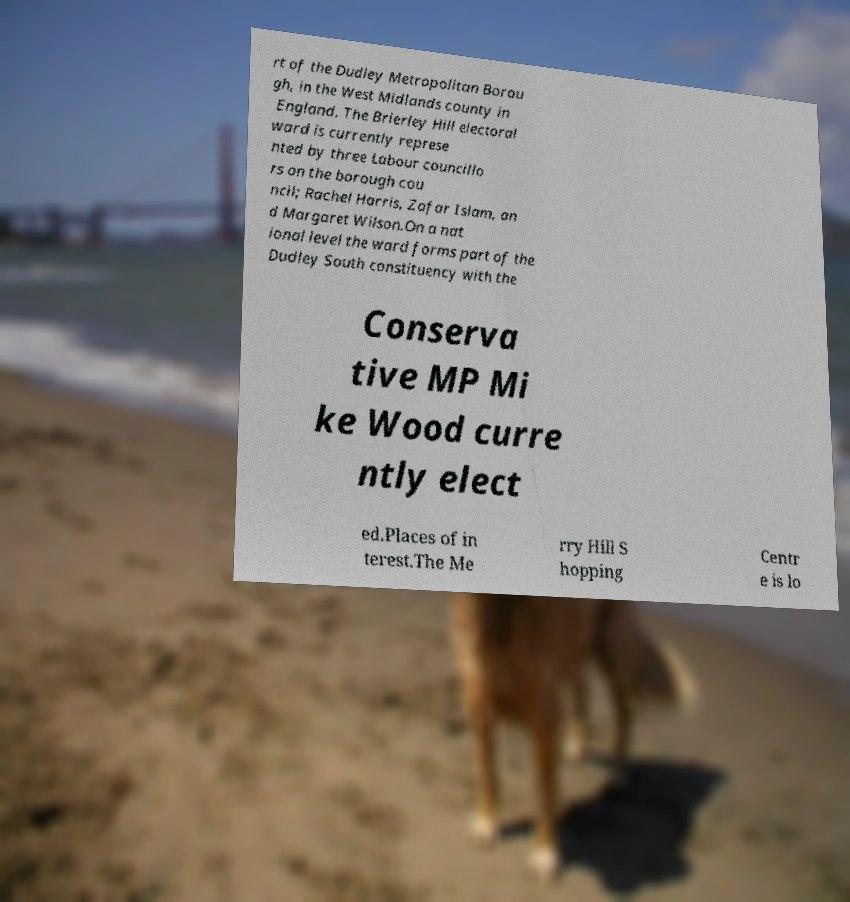Could you assist in decoding the text presented in this image and type it out clearly? rt of the Dudley Metropolitan Borou gh, in the West Midlands county in England. The Brierley Hill electoral ward is currently represe nted by three Labour councillo rs on the borough cou ncil; Rachel Harris, Zafar Islam, an d Margaret Wilson.On a nat ional level the ward forms part of the Dudley South constituency with the Conserva tive MP Mi ke Wood curre ntly elect ed.Places of in terest.The Me rry Hill S hopping Centr e is lo 